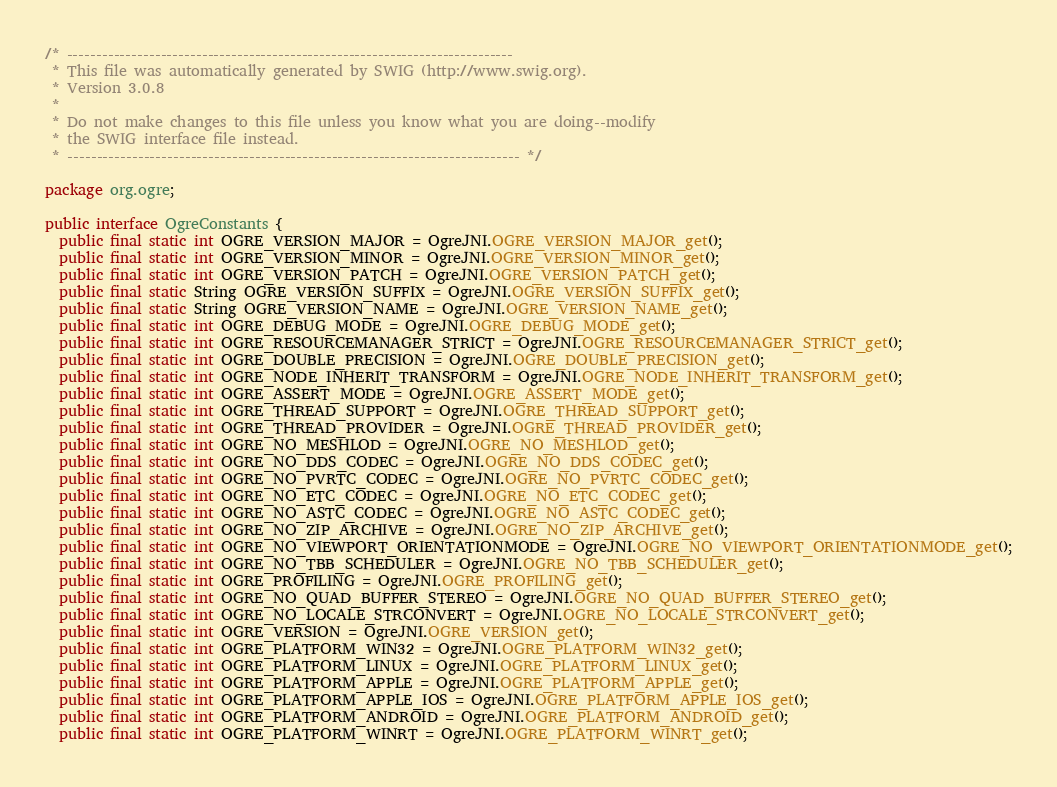Convert code to text. <code><loc_0><loc_0><loc_500><loc_500><_Java_>/* ----------------------------------------------------------------------------
 * This file was automatically generated by SWIG (http://www.swig.org).
 * Version 3.0.8
 *
 * Do not make changes to this file unless you know what you are doing--modify
 * the SWIG interface file instead.
 * ----------------------------------------------------------------------------- */

package org.ogre;

public interface OgreConstants {
  public final static int OGRE_VERSION_MAJOR = OgreJNI.OGRE_VERSION_MAJOR_get();
  public final static int OGRE_VERSION_MINOR = OgreJNI.OGRE_VERSION_MINOR_get();
  public final static int OGRE_VERSION_PATCH = OgreJNI.OGRE_VERSION_PATCH_get();
  public final static String OGRE_VERSION_SUFFIX = OgreJNI.OGRE_VERSION_SUFFIX_get();
  public final static String OGRE_VERSION_NAME = OgreJNI.OGRE_VERSION_NAME_get();
  public final static int OGRE_DEBUG_MODE = OgreJNI.OGRE_DEBUG_MODE_get();
  public final static int OGRE_RESOURCEMANAGER_STRICT = OgreJNI.OGRE_RESOURCEMANAGER_STRICT_get();
  public final static int OGRE_DOUBLE_PRECISION = OgreJNI.OGRE_DOUBLE_PRECISION_get();
  public final static int OGRE_NODE_INHERIT_TRANSFORM = OgreJNI.OGRE_NODE_INHERIT_TRANSFORM_get();
  public final static int OGRE_ASSERT_MODE = OgreJNI.OGRE_ASSERT_MODE_get();
  public final static int OGRE_THREAD_SUPPORT = OgreJNI.OGRE_THREAD_SUPPORT_get();
  public final static int OGRE_THREAD_PROVIDER = OgreJNI.OGRE_THREAD_PROVIDER_get();
  public final static int OGRE_NO_MESHLOD = OgreJNI.OGRE_NO_MESHLOD_get();
  public final static int OGRE_NO_DDS_CODEC = OgreJNI.OGRE_NO_DDS_CODEC_get();
  public final static int OGRE_NO_PVRTC_CODEC = OgreJNI.OGRE_NO_PVRTC_CODEC_get();
  public final static int OGRE_NO_ETC_CODEC = OgreJNI.OGRE_NO_ETC_CODEC_get();
  public final static int OGRE_NO_ASTC_CODEC = OgreJNI.OGRE_NO_ASTC_CODEC_get();
  public final static int OGRE_NO_ZIP_ARCHIVE = OgreJNI.OGRE_NO_ZIP_ARCHIVE_get();
  public final static int OGRE_NO_VIEWPORT_ORIENTATIONMODE = OgreJNI.OGRE_NO_VIEWPORT_ORIENTATIONMODE_get();
  public final static int OGRE_NO_TBB_SCHEDULER = OgreJNI.OGRE_NO_TBB_SCHEDULER_get();
  public final static int OGRE_PROFILING = OgreJNI.OGRE_PROFILING_get();
  public final static int OGRE_NO_QUAD_BUFFER_STEREO = OgreJNI.OGRE_NO_QUAD_BUFFER_STEREO_get();
  public final static int OGRE_NO_LOCALE_STRCONVERT = OgreJNI.OGRE_NO_LOCALE_STRCONVERT_get();
  public final static int OGRE_VERSION = OgreJNI.OGRE_VERSION_get();
  public final static int OGRE_PLATFORM_WIN32 = OgreJNI.OGRE_PLATFORM_WIN32_get();
  public final static int OGRE_PLATFORM_LINUX = OgreJNI.OGRE_PLATFORM_LINUX_get();
  public final static int OGRE_PLATFORM_APPLE = OgreJNI.OGRE_PLATFORM_APPLE_get();
  public final static int OGRE_PLATFORM_APPLE_IOS = OgreJNI.OGRE_PLATFORM_APPLE_IOS_get();
  public final static int OGRE_PLATFORM_ANDROID = OgreJNI.OGRE_PLATFORM_ANDROID_get();
  public final static int OGRE_PLATFORM_WINRT = OgreJNI.OGRE_PLATFORM_WINRT_get();</code> 